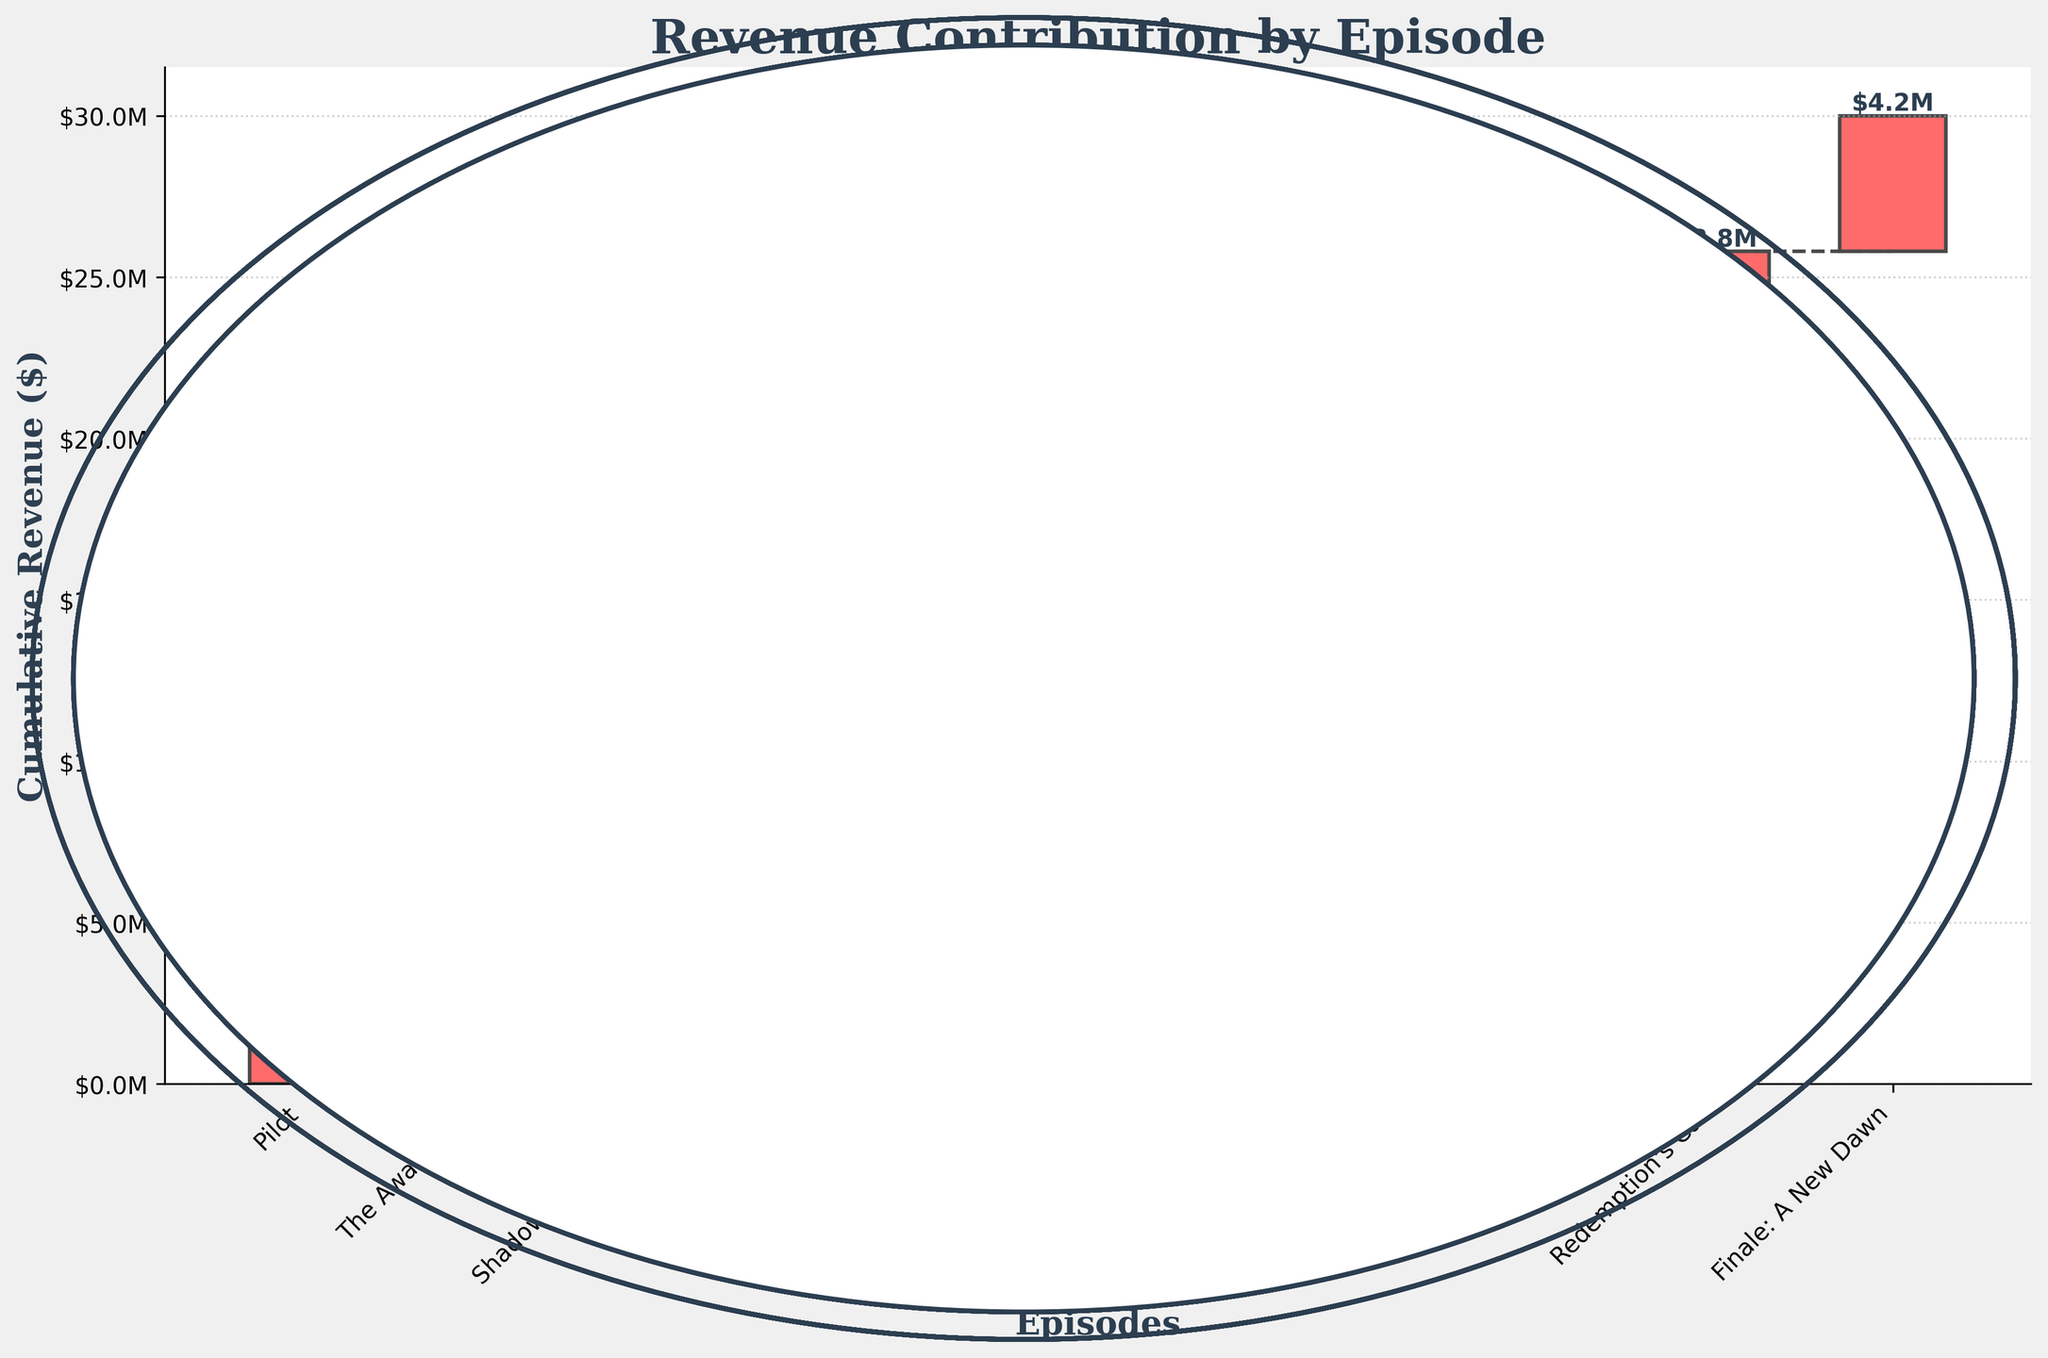What's the title of the chart? The chart's title is prominently displayed at the top of the figure.
Answer: Revenue Contribution by Episode How many episodes are represented in the chart? The x-axis labels represent the episodes, and counting them gives the total number.
Answer: 10 What is the cumulative revenue by the end of the series? The highest bar length represents the cumulative revenue for the final episode "Finale: A New Dawn."
Answer: $27.8M Which episode generated the highest revenue? By comparing the lengths of the individual bars for each episode, "Finale: A New Dawn" has the tallest bar.
Answer: Finale: A New Dawn What is the combined revenue from the first three episodes? Sum the revenues of "Pilot," "The Awakening," and "Shadows of the Past." The values are $2.5M, $1.8M, and $2.2M
Answer: $6.5M Which episode contributed the least to the total revenue? Compare the lengths of all bars to identify the shortest one, representing "The Awakening."
Answer: The Awakening What is the revenue difference between "Echoes in Time" and "Whispers in the Dark"? Subtract the revenue of "Whispers in the Dark" from "Echoes in Time." $2.9M - $2.7M
Answer: $0.2M How much cumulative revenue was reached by the midpoint of the season (after five episodes)? Calculate the cumulative sum of the first five episodes: $2.5M + $1.8M + $2.2M + $2.7M + $3.1M
Answer: $12.3M Which episode marks the first appearance of a revenue above $3M? Identify and compare the episodes' individual revenue bars. "The Turning Point" is the first to reach above $3M.
Answer: The Turning Point What is the difference in cumulative revenue between the second and ninth episodes? Calculate the cumulative sums for both episodes and subtract: $3.4M (second episode) from $24.8M (ninth episode)
Answer: $21.4M 